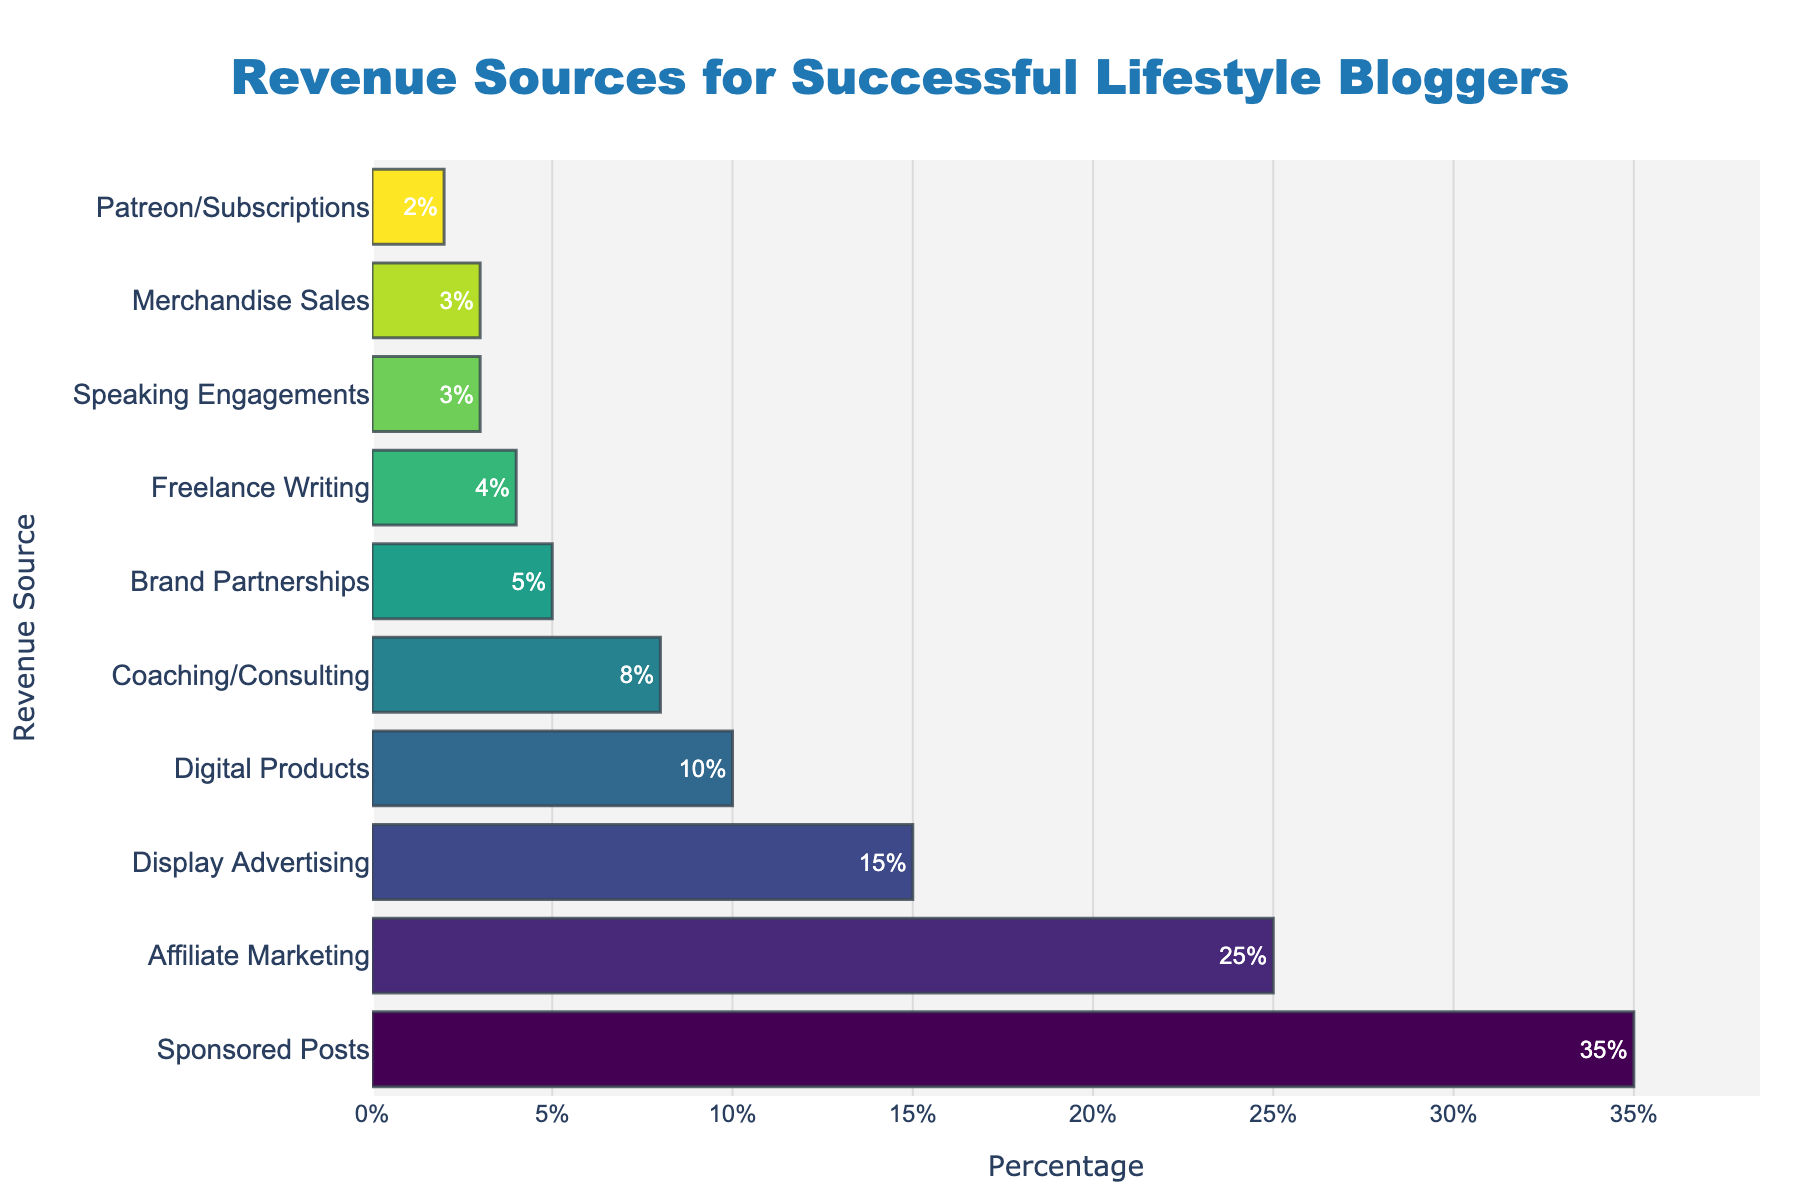Which revenue source contributes the most to the overall income? To determine the biggest contributor, we need to look at the bar with the highest percentage. The longest bar corresponds to Sponsored Posts, which accounts for 35%, making it the top revenue source.
Answer: Sponsored Posts What is the combined percentage of revenue from Digital Products and Coaching/Consulting? Locate the bars for Digital Products and Coaching/Consulting. The percentages for these are 10% and 8%, respectively. Adding them together, the combined percentage is 10% + 8% = 18%.
Answer: 18% Which revenue source has a higher percentage contribution: Brand Partnerships or Patreon/Subscriptions? Compare the bars for Brand Partnerships and Patreon/Subscriptions. Brand Partnerships has 5%, whereas Patreon/Subscriptions has 2%. Therefore, Brand Partnerships has a higher percentage.
Answer: Brand Partnerships How much more percentage does Sponsored Posts contribute compared to Display Advertising? Identify the bars for Sponsored Posts (35%) and Display Advertising (15%). The difference is 35% - 15% = 20%.
Answer: 20% What is the average percentage contribution of Affiliate Marketing, Display Advertising, and Digital Products? Locate the bars for Affiliate Marketing (25%), Display Advertising (15%), and Digital Products (10%). The average is calculated as (25% + 15% + 10%) / 3 = 50% / 3 ≈ 16.67%.
Answer: 16.67% Which category has the least revenue contribution, and what is its percentage? Find the shortest bar, which is for Patreon/Subscriptions with 2%. This indicates it is the category with the least revenue contribution.
Answer: Patreon/Subscriptions Are there any revenue sources with equal contributions? If so, which ones and what is their percentage? Examine the bars to see if any have the same length. Merchandise Sales and Speaking Engagements both have 3%, showing they have equal contributions.
Answer: Merchandise Sales and Speaking Engagements; 3% What is the total percentage revenue contribution from the top three revenue sources? The top three revenue sources are Sponsored Posts (35%), Affiliate Marketing (25%), and Display Advertising (15%). Adding them together: 35% + 25% + 15% = 75%.
Answer: 75% Is the contribution of Freelance Writing higher or lower than Coaching/Consulting? Compare the bars for Freelance Writing (4%) and Coaching/Consulting (8%). Freelance Writing has a lower contribution.
Answer: Lower What is the difference in percentage between the highest and lowest revenue sources? The highest is Sponsored Posts with 35%, and the lowest is Patreon/Subscriptions with 2%. The difference is 35% - 2% = 33%.
Answer: 33% 